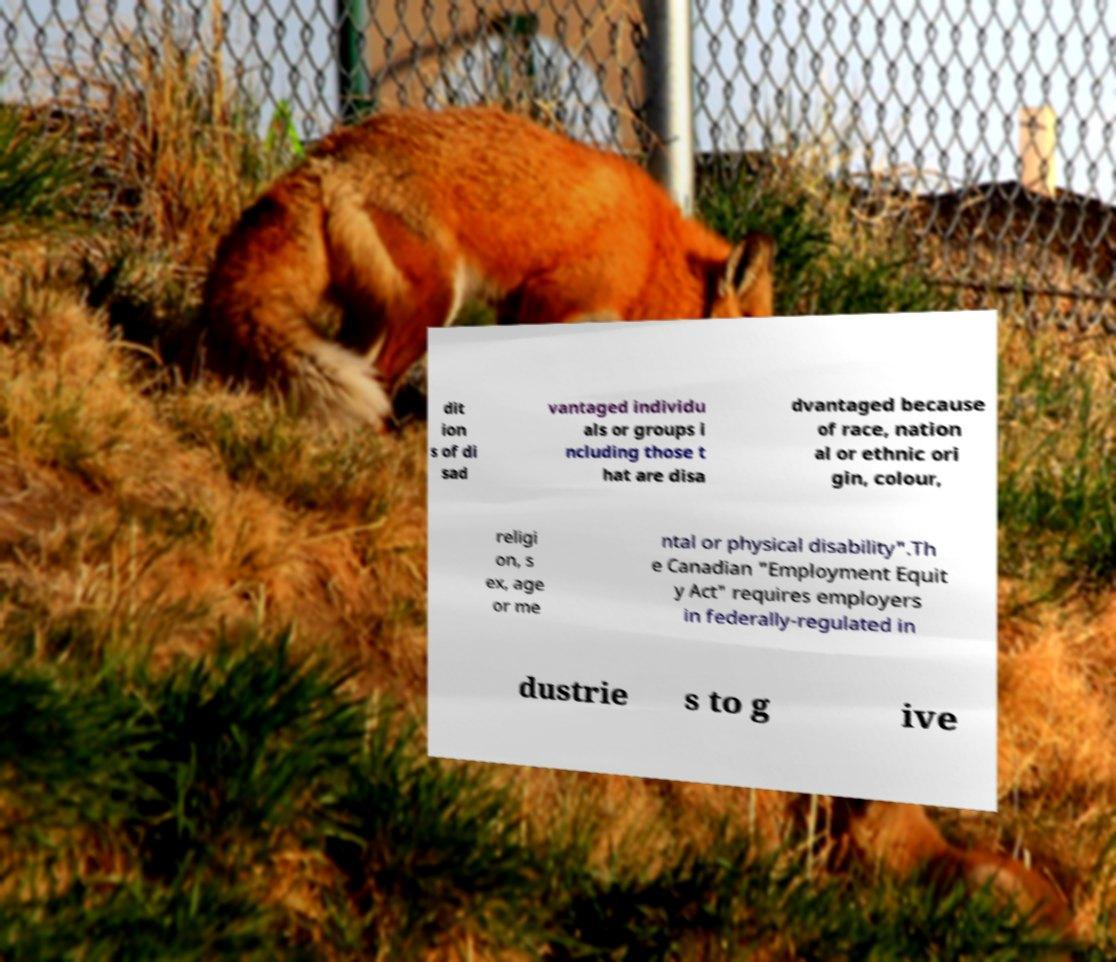Could you extract and type out the text from this image? dit ion s of di sad vantaged individu als or groups i ncluding those t hat are disa dvantaged because of race, nation al or ethnic ori gin, colour, religi on, s ex, age or me ntal or physical disability".Th e Canadian "Employment Equit y Act" requires employers in federally-regulated in dustrie s to g ive 